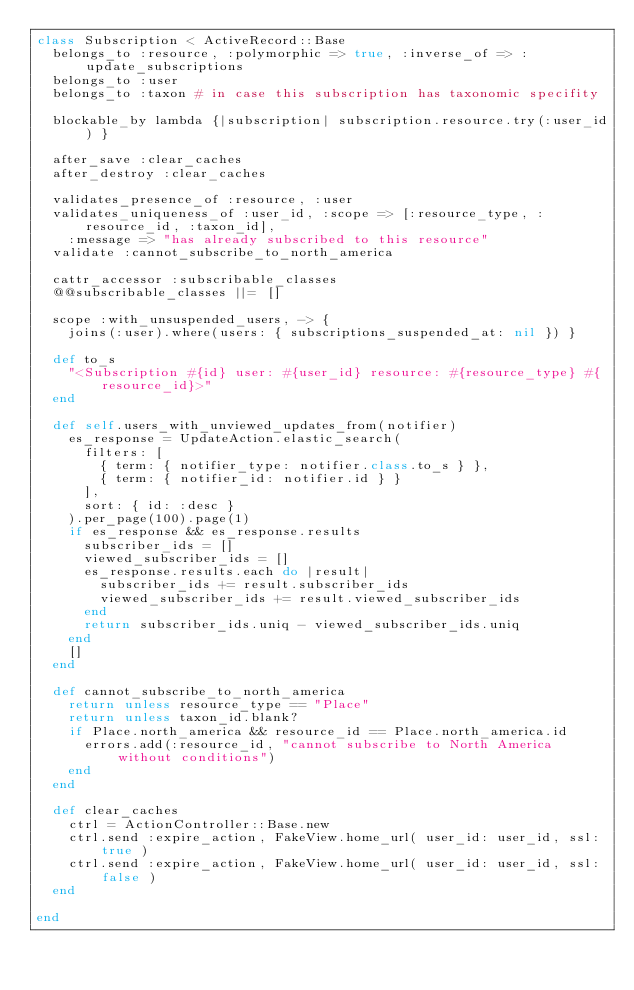<code> <loc_0><loc_0><loc_500><loc_500><_Ruby_>class Subscription < ActiveRecord::Base
  belongs_to :resource, :polymorphic => true, :inverse_of => :update_subscriptions
  belongs_to :user
  belongs_to :taxon # in case this subscription has taxonomic specifity

  blockable_by lambda {|subscription| subscription.resource.try(:user_id) }

  after_save :clear_caches
  after_destroy :clear_caches
  
  validates_presence_of :resource, :user
  validates_uniqueness_of :user_id, :scope => [:resource_type, :resource_id, :taxon_id], 
    :message => "has already subscribed to this resource"
  validate :cannot_subscribe_to_north_america

  cattr_accessor :subscribable_classes
  @@subscribable_classes ||= []

  scope :with_unsuspended_users, -> {
    joins(:user).where(users: { subscriptions_suspended_at: nil }) }

  def to_s
    "<Subscription #{id} user: #{user_id} resource: #{resource_type} #{resource_id}>"
  end

  def self.users_with_unviewed_updates_from(notifier)
    es_response = UpdateAction.elastic_search(
      filters: [
        { term: { notifier_type: notifier.class.to_s } },
        { term: { notifier_id: notifier.id } }
      ],
      sort: { id: :desc }
    ).per_page(100).page(1)
    if es_response && es_response.results
      subscriber_ids = []
      viewed_subscriber_ids = []
      es_response.results.each do |result|
        subscriber_ids += result.subscriber_ids
        viewed_subscriber_ids += result.viewed_subscriber_ids
      end
      return subscriber_ids.uniq - viewed_subscriber_ids.uniq
    end
    []
  end

  def cannot_subscribe_to_north_america
    return unless resource_type == "Place"
    return unless taxon_id.blank?
    if Place.north_america && resource_id == Place.north_america.id
      errors.add(:resource_id, "cannot subscribe to North America without conditions")
    end
  end

  def clear_caches
    ctrl = ActionController::Base.new
    ctrl.send :expire_action, FakeView.home_url( user_id: user_id, ssl: true )
    ctrl.send :expire_action, FakeView.home_url( user_id: user_id, ssl: false )
  end

end
</code> 